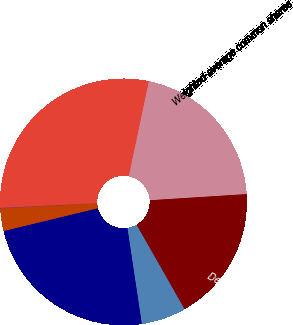Convert chart to OTSL. <chart><loc_0><loc_0><loc_500><loc_500><pie_chart><fcel>Net income<fcel>Weighted-average common shares<fcel>Denominator for basic<fcel>Employee stock options<fcel>Total shares for purpose of<fcel>Basic<fcel>Diluted<nl><fcel>29.09%<fcel>20.68%<fcel>17.78%<fcel>5.86%<fcel>23.59%<fcel>2.95%<fcel>0.05%<nl></chart> 